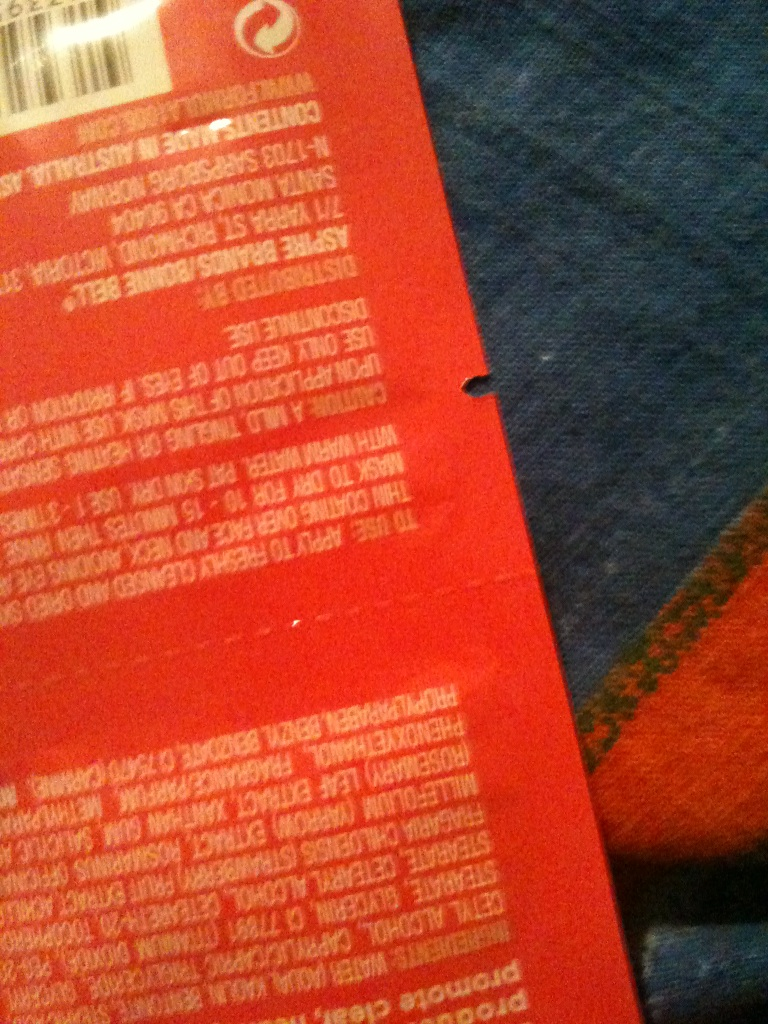Can you see if this is shampoo or what it is? If possible. from Vizwiz While the image is blurry and the text is not fully legible, the visible packaging characteristics and the partial wording suggest it may indeed be a personal care product, possibly shampoo or a related item. For a more accurate determination, I would recommend examining the item directly or providing a clearer image. 